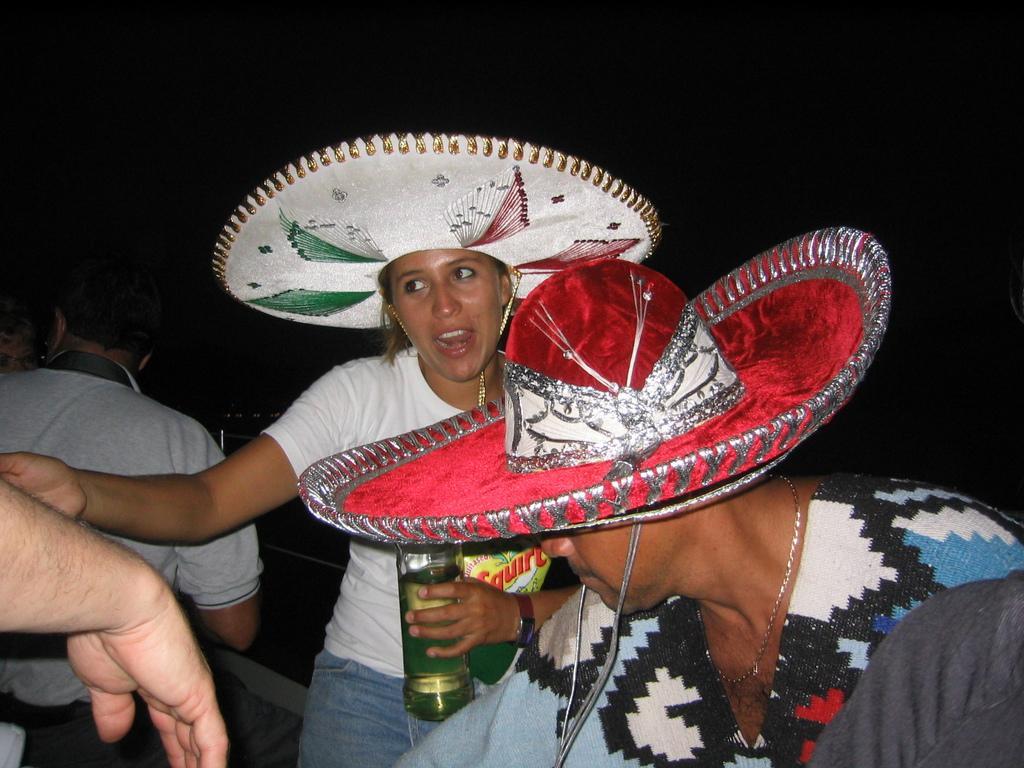How would you summarize this image in a sentence or two? In this image, we can see two persons wearing clothes and hats. There is a person in the middle of the image holding a bottle with her hand. There is an another person on the left side of the image. 